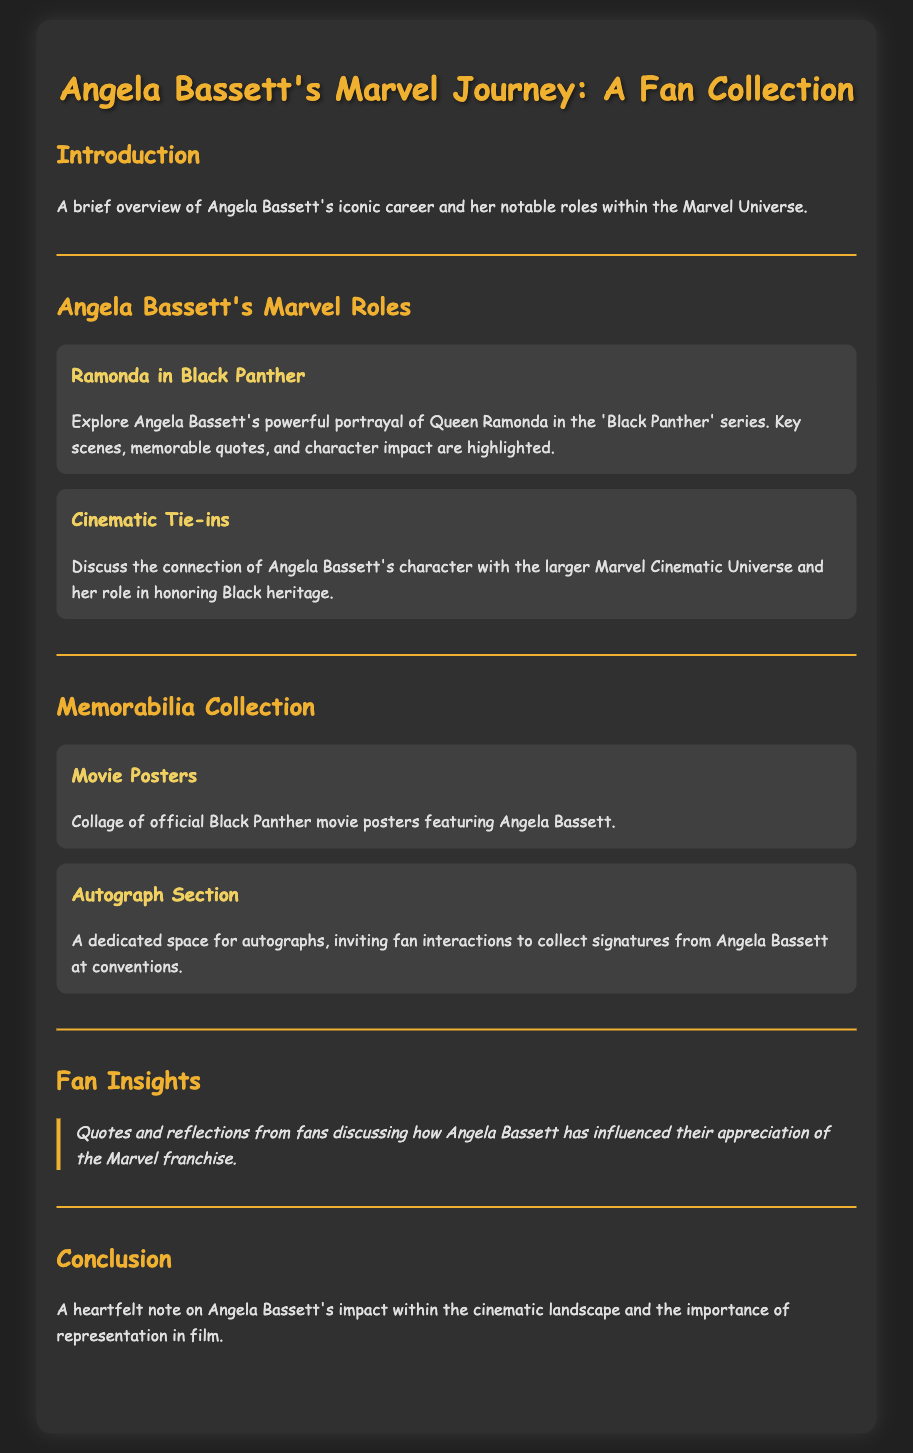What is the title of the document? The title of the document is indicated at the top of the rendered page.
Answer: Angela Bassett's Marvel Journey: A Fan Collection Who played Ramonda in Black Panther? The document states Angela Bassett portrayed this character in Black Panther.
Answer: Angela Bassett What are included in the memorabilia collection? The document lists specific items that are part of the memorabilia collection.
Answer: Movie Posters, Autograph Section What is one key theme discussed in Angela Bassett's Marvel roles? The document mentions a significant theme present in her roles within the Marvel Universe.
Answer: Honoring Black heritage What type of insights are shared in the fan insights section? The document describes the content and focus of the fan insights provided.
Answer: Quotes and reflections How many sections are there in the menu? By counting the distinct sections listed in the document, we can determine this number.
Answer: Five What color is the background of the document designed to be? The document includes a style attribute that indicates the background color of the body.
Answer: #202020 What impact does the conclusion note about Angela Bassett? The conclusion section provides an overview of her significance touched upon in the document.
Answer: Representation in film 